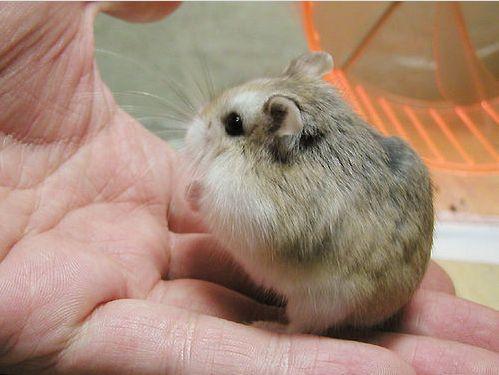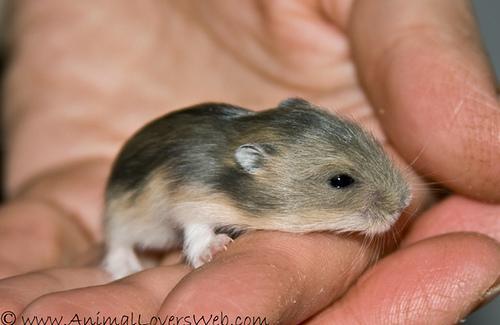The first image is the image on the left, the second image is the image on the right. For the images shown, is this caption "A mouse is asleep in at least one of the images." true? Answer yes or no. No. The first image is the image on the left, the second image is the image on the right. Analyze the images presented: Is the assertion "In each image, one hand is palm up holding one pet rodent." valid? Answer yes or no. Yes. 